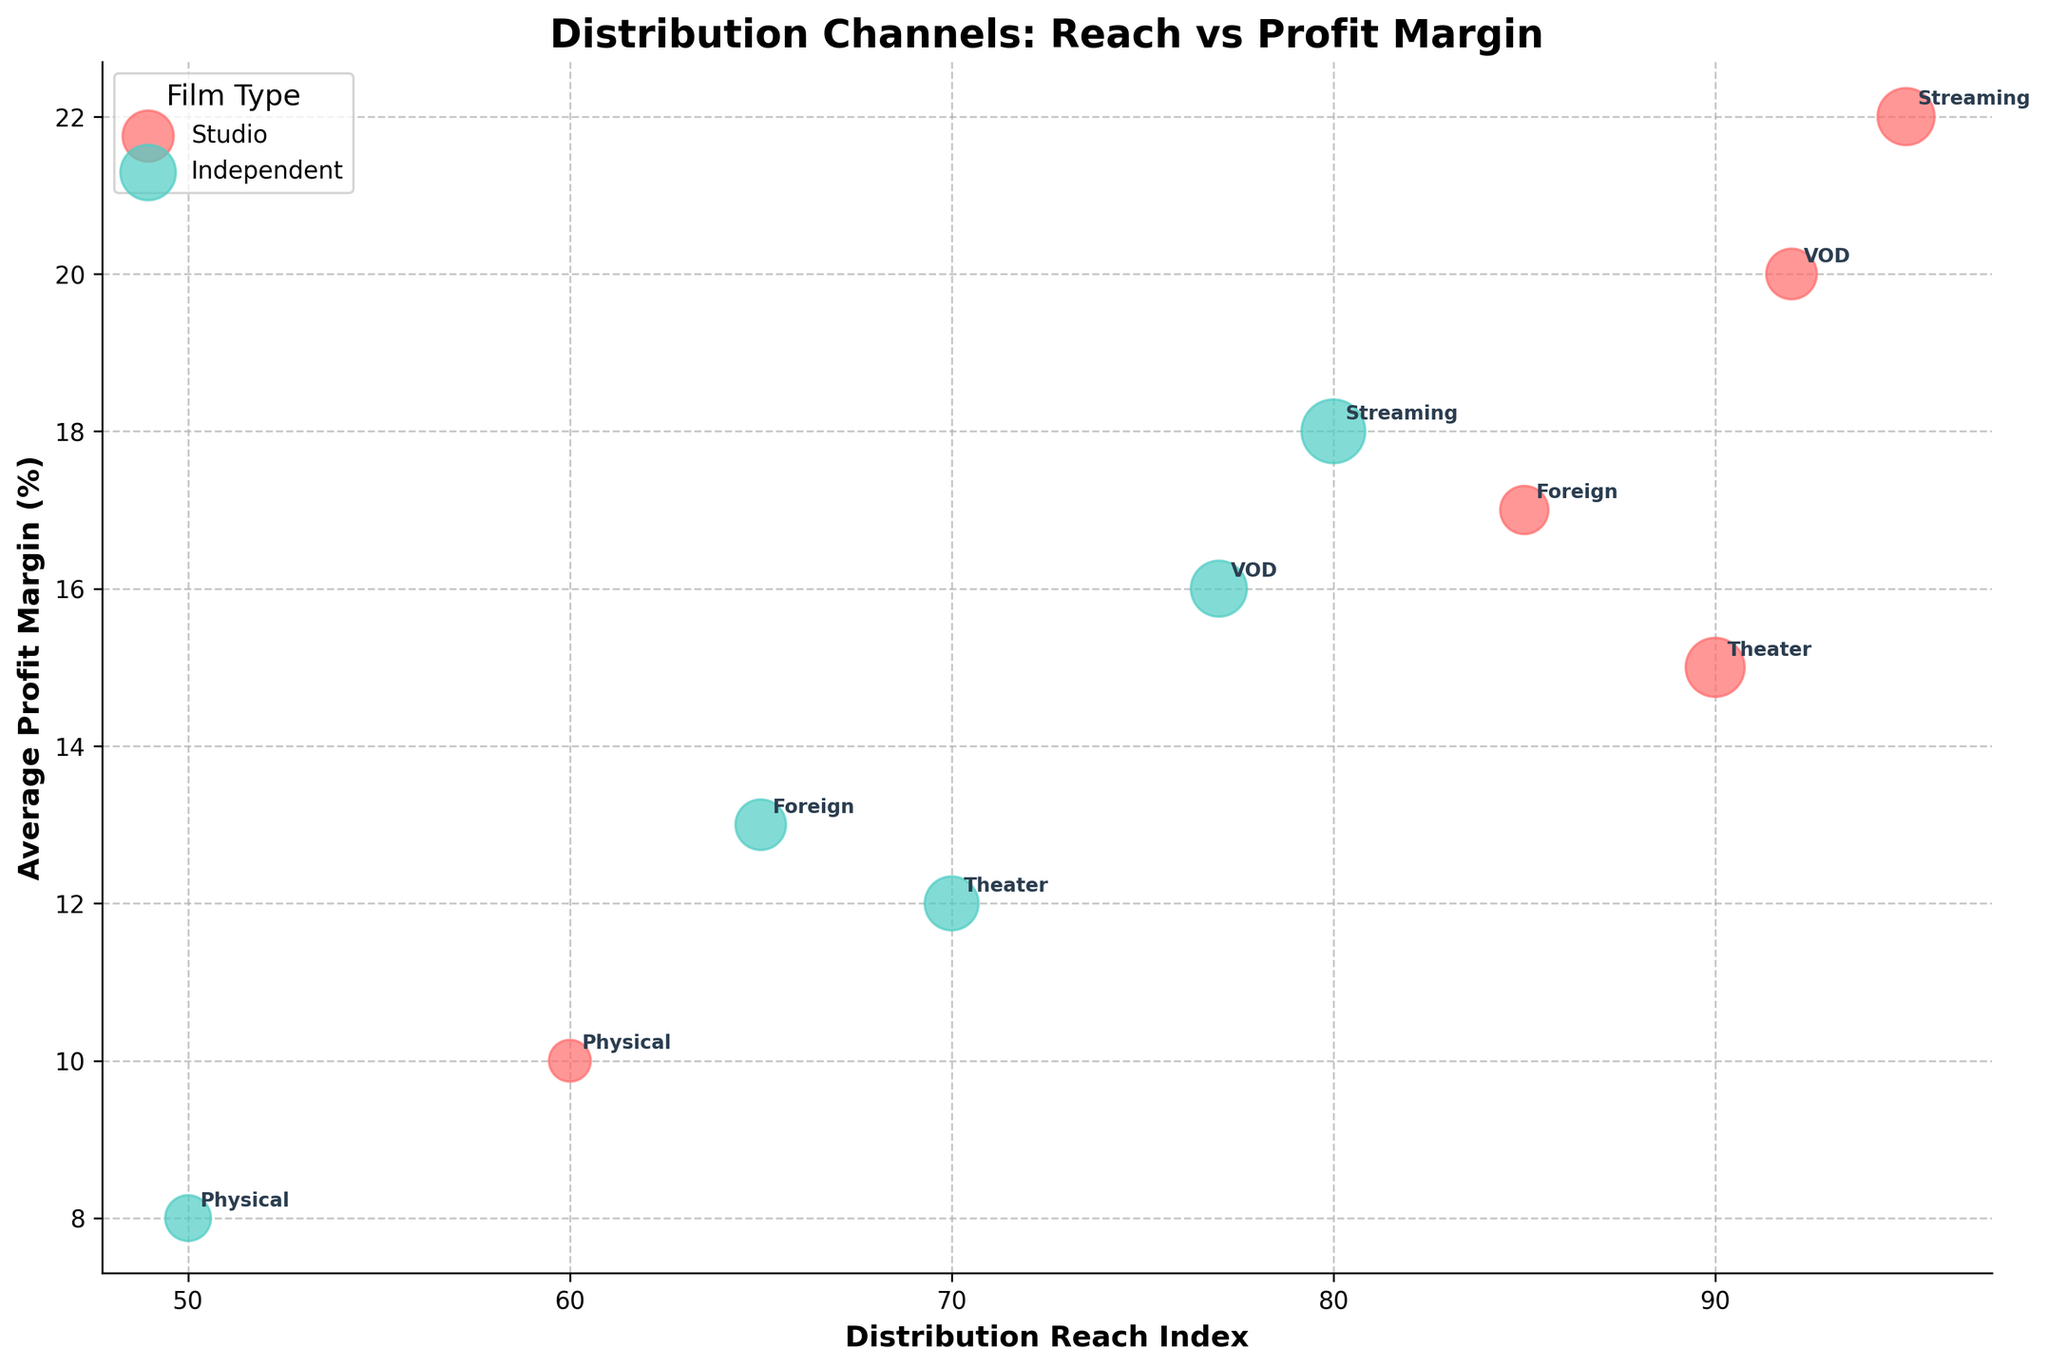what's the title of the figure? The title of the figure is found at the top and describes the focus of the visualization. In this figure, the title is "Distribution Channels: Reach vs Profit Margin".
Answer: Distribution Channels: Reach vs Profit Margin what are the two types of films shown in the figure? The two types of films are mentioned in the legend on the upper left part of the figure. The types are "Studio" and "Independent".
Answer: Studio, Independent which distribution channel has the highest average profit margin for studio films? The "Streaming" distribution channel for studio films has the highest average profit margin. This can be determined by finding the highest position on the y-axis among the studio films.
Answer: Streaming which film type has a higher number of films in the physical media distribution channel? Look for the bubble size for "Physical Media". The number of films for "Physical Media Independent" is higher as the bubble for independent films is larger than that for studio films.
Answer: Independent which distribution channel for independent films has the highest distribution reach index? Check the x-axis for the highest value among the independent films. "Streaming" has the highest distribution reach index for independent films.
Answer: Streaming which independent film distribution channel has the lowest average profit margin? On the y-axis, the lowest position among the bubbles representing independent films will show the channel. "Physical Media Independent" has the lowest average profit margin.
Answer: Physical Media what is the total number of independent films across all distribution channels? Sum up the number of films for each independent distribution channel: (25 + 35 + 18 + 22 + 27) = 127.
Answer: 127 which distribution channel has the closest distribution reach index for both studio and independent films? Compare the positions on the x-axis for both types of films. "Theater" has a similar distribution reach index for both Studio and Independent films, close to 90 and 70 respectively.
Answer: Theater how does the average profit margin of streaming compare between studio and independent films? The streaming average profit margin for studio films is 22% and for independent films is 18%. The studio films have a higher average profit margin.
Answer: Studio films have a higher margin 